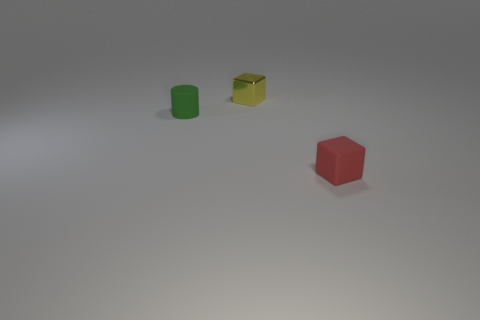Is there a red rubber thing that is behind the tiny block in front of the block that is behind the small green rubber cylinder?
Your answer should be compact. No. What is the cylinder made of?
Your answer should be very brief. Rubber. What number of other objects are there of the same shape as the small yellow object?
Your response must be concise. 1. Is the shape of the metallic thing the same as the green matte object?
Ensure brevity in your answer.  No. What number of objects are either tiny things that are left of the small yellow metal thing or tiny rubber objects behind the small matte cube?
Provide a short and direct response. 1. What number of things are blue metallic blocks or red objects?
Offer a terse response. 1. How many small green matte cylinders are in front of the tiny cube that is to the left of the red cube?
Your response must be concise. 1. What number of other objects are there of the same size as the rubber cube?
Give a very brief answer. 2. Does the matte object to the right of the matte cylinder have the same shape as the yellow shiny object?
Offer a terse response. Yes. What material is the small block behind the red rubber cube?
Your answer should be compact. Metal. 